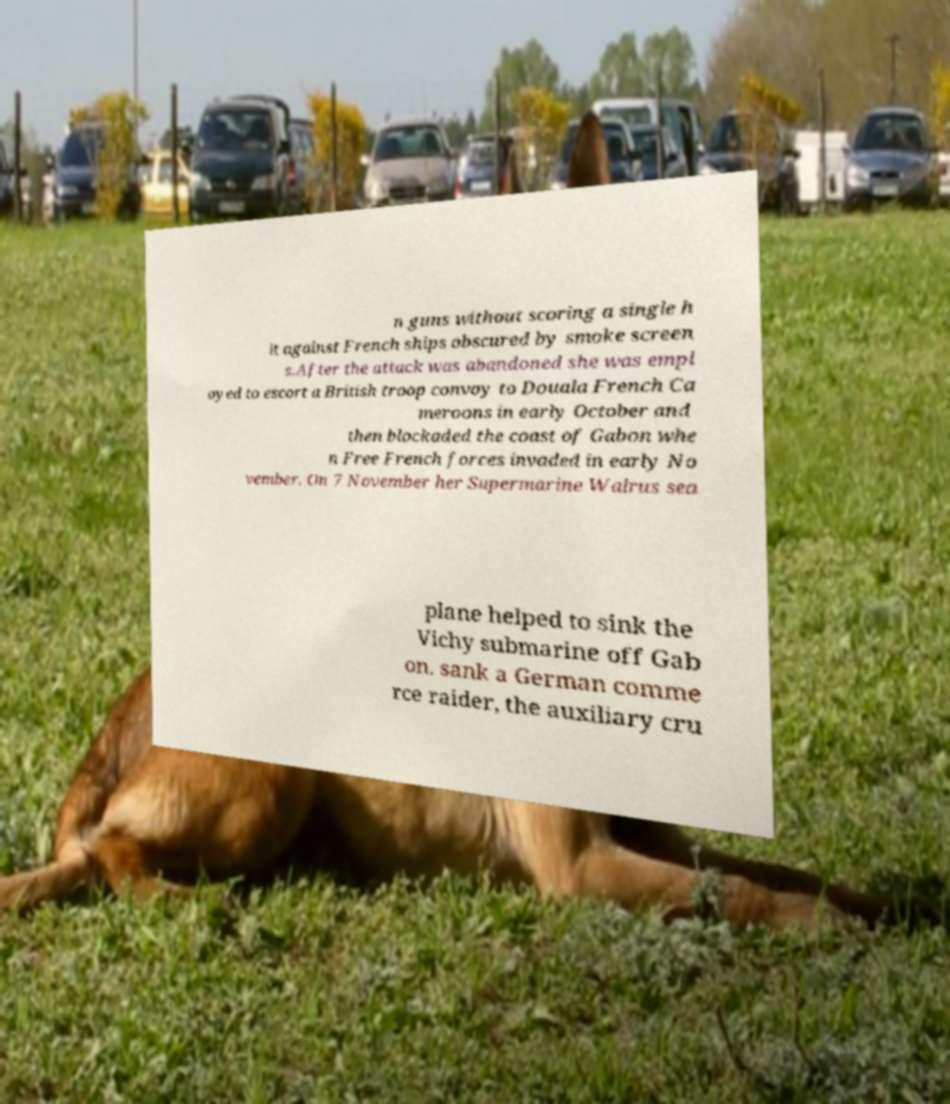What messages or text are displayed in this image? I need them in a readable, typed format. n guns without scoring a single h it against French ships obscured by smoke screen s.After the attack was abandoned she was empl oyed to escort a British troop convoy to Douala French Ca meroons in early October and then blockaded the coast of Gabon whe n Free French forces invaded in early No vember. On 7 November her Supermarine Walrus sea plane helped to sink the Vichy submarine off Gab on. sank a German comme rce raider, the auxiliary cru 